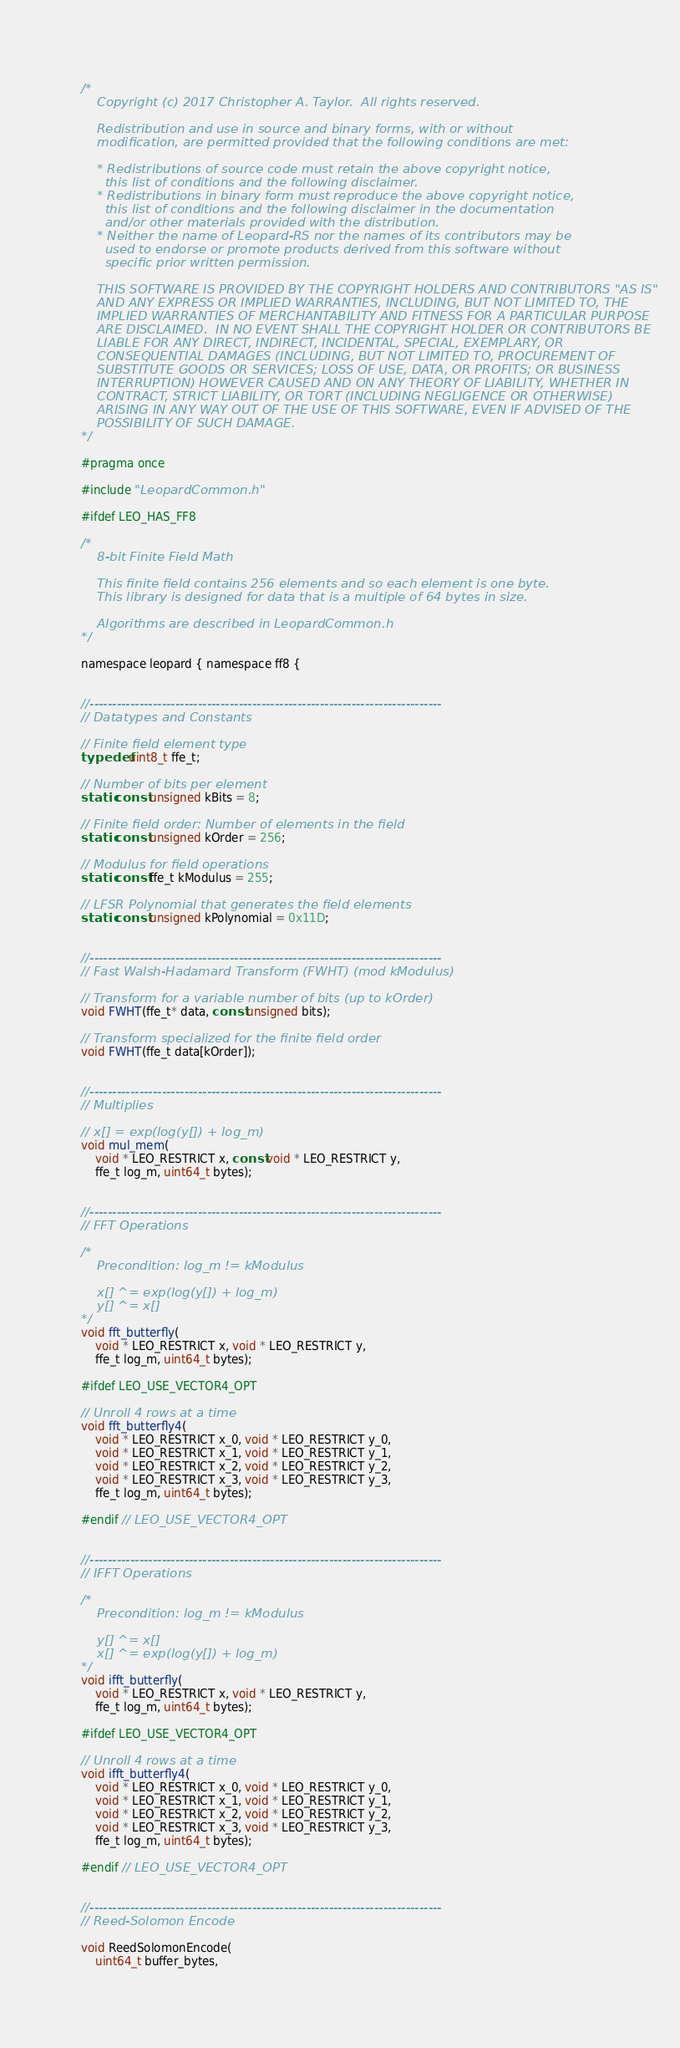Convert code to text. <code><loc_0><loc_0><loc_500><loc_500><_C_>/*
    Copyright (c) 2017 Christopher A. Taylor.  All rights reserved.

    Redistribution and use in source and binary forms, with or without
    modification, are permitted provided that the following conditions are met:

    * Redistributions of source code must retain the above copyright notice,
      this list of conditions and the following disclaimer.
    * Redistributions in binary form must reproduce the above copyright notice,
      this list of conditions and the following disclaimer in the documentation
      and/or other materials provided with the distribution.
    * Neither the name of Leopard-RS nor the names of its contributors may be
      used to endorse or promote products derived from this software without
      specific prior written permission.

    THIS SOFTWARE IS PROVIDED BY THE COPYRIGHT HOLDERS AND CONTRIBUTORS "AS IS"
    AND ANY EXPRESS OR IMPLIED WARRANTIES, INCLUDING, BUT NOT LIMITED TO, THE
    IMPLIED WARRANTIES OF MERCHANTABILITY AND FITNESS FOR A PARTICULAR PURPOSE
    ARE DISCLAIMED.  IN NO EVENT SHALL THE COPYRIGHT HOLDER OR CONTRIBUTORS BE
    LIABLE FOR ANY DIRECT, INDIRECT, INCIDENTAL, SPECIAL, EXEMPLARY, OR
    CONSEQUENTIAL DAMAGES (INCLUDING, BUT NOT LIMITED TO, PROCUREMENT OF
    SUBSTITUTE GOODS OR SERVICES; LOSS OF USE, DATA, OR PROFITS; OR BUSINESS
    INTERRUPTION) HOWEVER CAUSED AND ON ANY THEORY OF LIABILITY, WHETHER IN
    CONTRACT, STRICT LIABILITY, OR TORT (INCLUDING NEGLIGENCE OR OTHERWISE)
    ARISING IN ANY WAY OUT OF THE USE OF THIS SOFTWARE, EVEN IF ADVISED OF THE
    POSSIBILITY OF SUCH DAMAGE.
*/

#pragma once

#include "LeopardCommon.h"

#ifdef LEO_HAS_FF8

/*
    8-bit Finite Field Math

    This finite field contains 256 elements and so each element is one byte.
    This library is designed for data that is a multiple of 64 bytes in size.

    Algorithms are described in LeopardCommon.h
*/

namespace leopard { namespace ff8 {


//------------------------------------------------------------------------------
// Datatypes and Constants

// Finite field element type
typedef uint8_t ffe_t;

// Number of bits per element
static const unsigned kBits = 8;

// Finite field order: Number of elements in the field
static const unsigned kOrder = 256;

// Modulus for field operations
static const ffe_t kModulus = 255;

// LFSR Polynomial that generates the field elements
static const unsigned kPolynomial = 0x11D;


//------------------------------------------------------------------------------
// Fast Walsh-Hadamard Transform (FWHT) (mod kModulus)

// Transform for a variable number of bits (up to kOrder)
void FWHT(ffe_t* data, const unsigned bits);

// Transform specialized for the finite field order
void FWHT(ffe_t data[kOrder]);


//------------------------------------------------------------------------------
// Multiplies

// x[] = exp(log(y[]) + log_m)
void mul_mem(
    void * LEO_RESTRICT x, const void * LEO_RESTRICT y,
    ffe_t log_m, uint64_t bytes);


//------------------------------------------------------------------------------
// FFT Operations

/*
    Precondition: log_m != kModulus

    x[] ^= exp(log(y[]) + log_m)
    y[] ^= x[]
*/
void fft_butterfly(
    void * LEO_RESTRICT x, void * LEO_RESTRICT y,
    ffe_t log_m, uint64_t bytes);

#ifdef LEO_USE_VECTOR4_OPT

// Unroll 4 rows at a time
void fft_butterfly4(
    void * LEO_RESTRICT x_0, void * LEO_RESTRICT y_0,
    void * LEO_RESTRICT x_1, void * LEO_RESTRICT y_1,
    void * LEO_RESTRICT x_2, void * LEO_RESTRICT y_2,
    void * LEO_RESTRICT x_3, void * LEO_RESTRICT y_3,
    ffe_t log_m, uint64_t bytes);

#endif // LEO_USE_VECTOR4_OPT


//------------------------------------------------------------------------------
// IFFT Operations

/*
    Precondition: log_m != kModulus

    y[] ^= x[]
    x[] ^= exp(log(y[]) + log_m)
*/
void ifft_butterfly(
    void * LEO_RESTRICT x, void * LEO_RESTRICT y,
    ffe_t log_m, uint64_t bytes);

#ifdef LEO_USE_VECTOR4_OPT

// Unroll 4 rows at a time
void ifft_butterfly4(
    void * LEO_RESTRICT x_0, void * LEO_RESTRICT y_0,
    void * LEO_RESTRICT x_1, void * LEO_RESTRICT y_1,
    void * LEO_RESTRICT x_2, void * LEO_RESTRICT y_2,
    void * LEO_RESTRICT x_3, void * LEO_RESTRICT y_3,
    ffe_t log_m, uint64_t bytes);

#endif // LEO_USE_VECTOR4_OPT


//------------------------------------------------------------------------------
// Reed-Solomon Encode

void ReedSolomonEncode(
    uint64_t buffer_bytes,</code> 